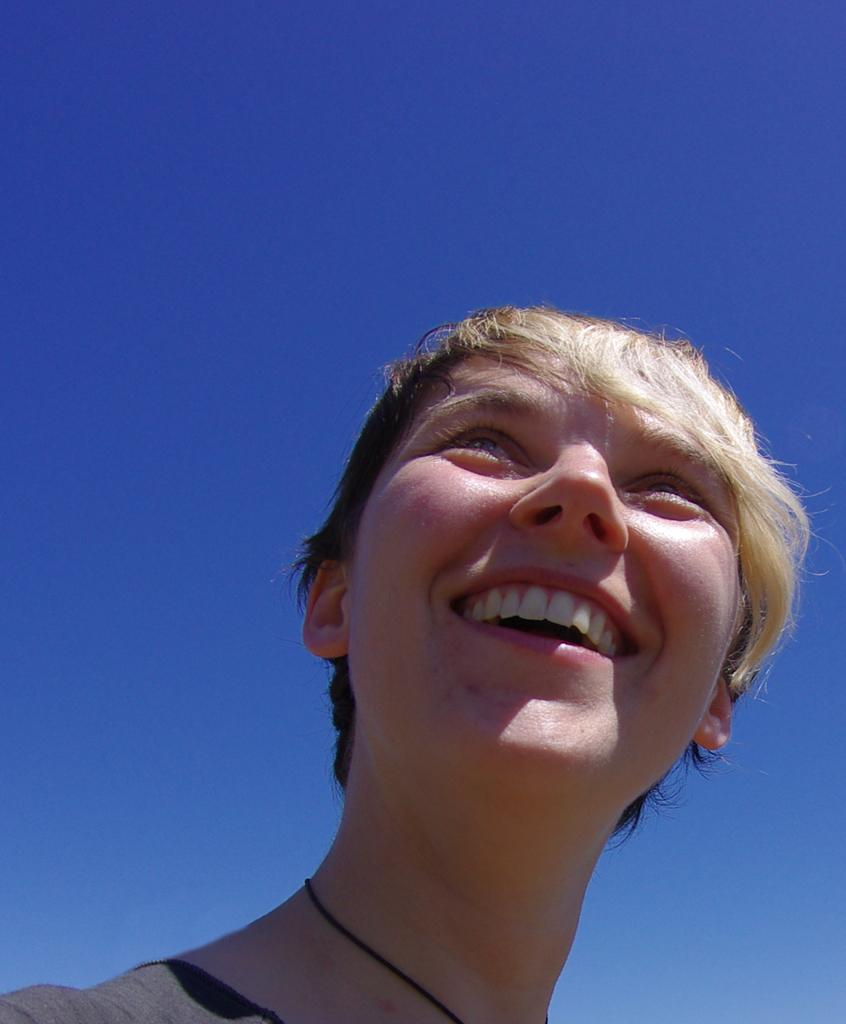Who is the main subject in the foreground of the image? There is a woman in the foreground of the image. What is the woman doing in the image? The woman is smiling. What can be seen in the background of the image? The sky is visible in the background of the image. What type of cream is being used by the hen in the image? There is no hen or cream present in the image. 